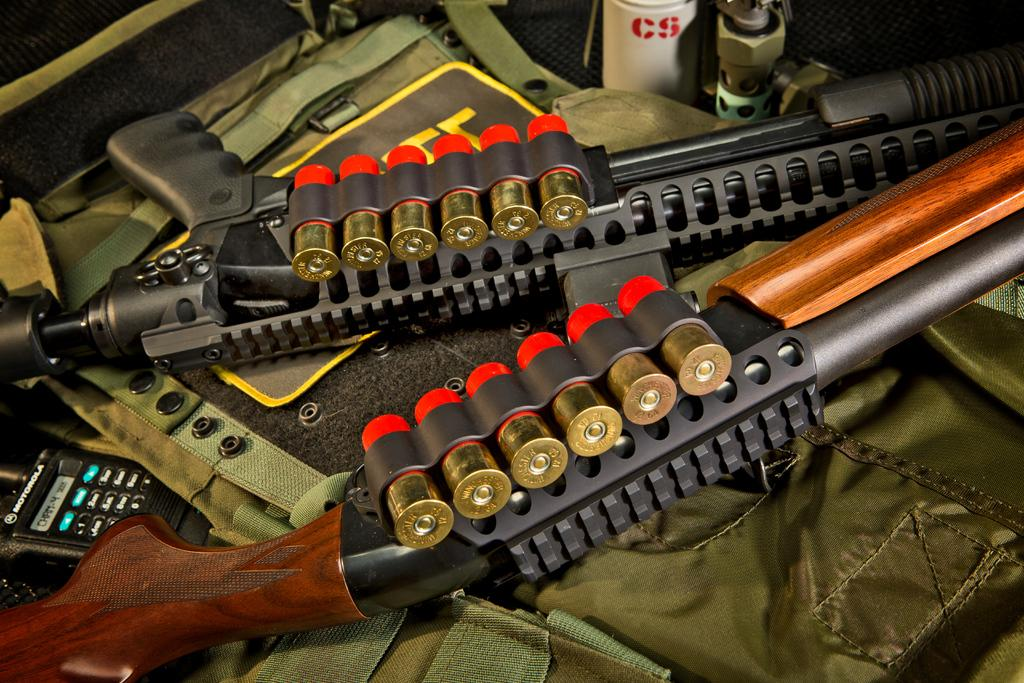What type of weapons are present in the image? There are guns with bullets in the image. How are the guns stored or carried in the image? There is a gun bag in the image. What other item can be seen in the image? There is a device in the image. Can you describe any other objects in the image? There are other unspecified objects in the image. What type of hill can be seen in the background of the image? There is no hill present in the image; it only features guns, a gun bag, a device, and other unspecified objects. 